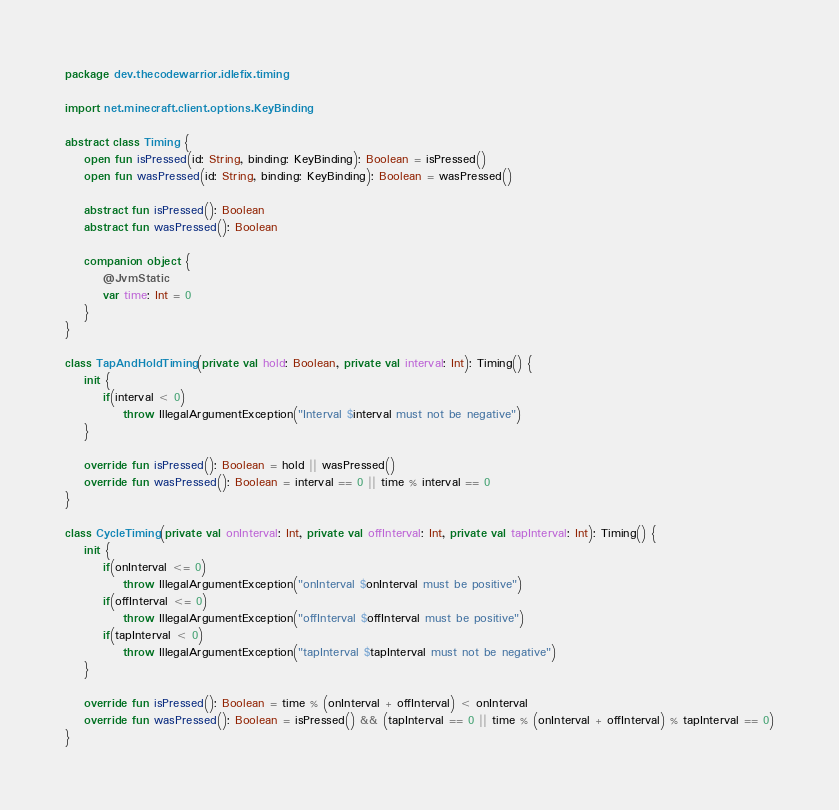<code> <loc_0><loc_0><loc_500><loc_500><_Kotlin_>package dev.thecodewarrior.idlefix.timing

import net.minecraft.client.options.KeyBinding

abstract class Timing {
    open fun isPressed(id: String, binding: KeyBinding): Boolean = isPressed()
    open fun wasPressed(id: String, binding: KeyBinding): Boolean = wasPressed()

    abstract fun isPressed(): Boolean
    abstract fun wasPressed(): Boolean

    companion object {
        @JvmStatic
        var time: Int = 0
    }
}

class TapAndHoldTiming(private val hold: Boolean, private val interval: Int): Timing() {
    init {
        if(interval < 0)
            throw IllegalArgumentException("Interval $interval must not be negative")
    }

    override fun isPressed(): Boolean = hold || wasPressed()
    override fun wasPressed(): Boolean = interval == 0 || time % interval == 0
}

class CycleTiming(private val onInterval: Int, private val offInterval: Int, private val tapInterval: Int): Timing() {
    init {
        if(onInterval <= 0)
            throw IllegalArgumentException("onInterval $onInterval must be positive")
        if(offInterval <= 0)
            throw IllegalArgumentException("offInterval $offInterval must be positive")
        if(tapInterval < 0)
            throw IllegalArgumentException("tapInterval $tapInterval must not be negative")
    }

    override fun isPressed(): Boolean = time % (onInterval + offInterval) < onInterval
    override fun wasPressed(): Boolean = isPressed() && (tapInterval == 0 || time % (onInterval + offInterval) % tapInterval == 0)
}

</code> 